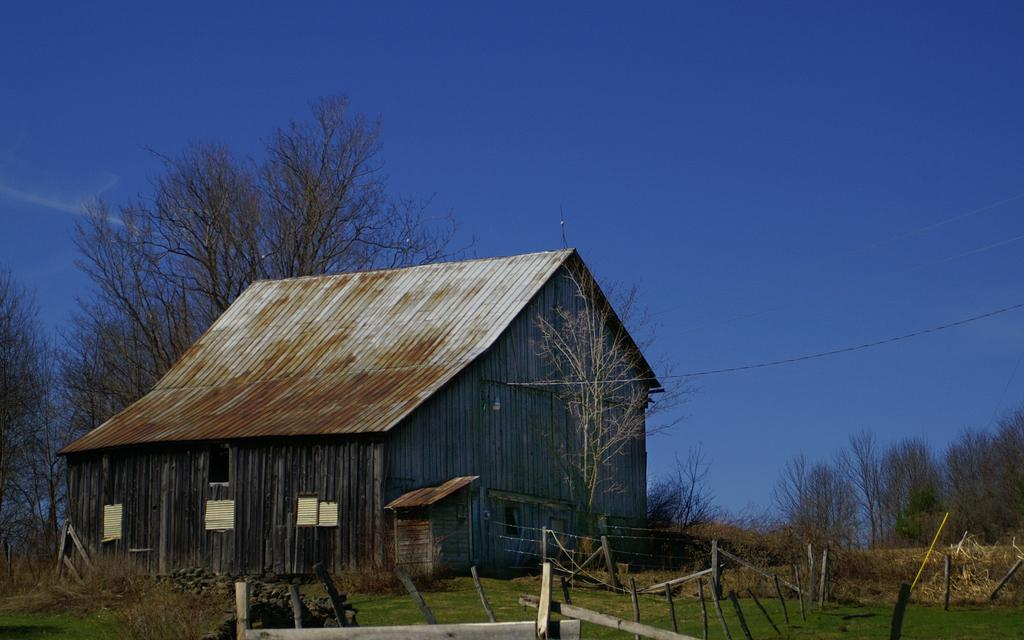What type of structure is visible in the image? There is a house in the image. What is located in front of the house? There is a fence wire and wooden poles in front of the house. What type of vegetation is visible in front of the house? There are trees in front of the house. What can be seen in the background of the image? There are more trees visible in the background, and the sky is blue. How many pencils are being distributed by the man in the image? There is no man present in the image, and therefore no pencils or distribution can be observed. 